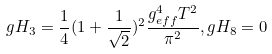<formula> <loc_0><loc_0><loc_500><loc_500>g H _ { 3 } = \frac { 1 } { 4 } ( 1 + \frac { 1 } { \sqrt { 2 } } ) ^ { 2 } \frac { g _ { e f f } ^ { 4 } T ^ { 2 } } { \pi ^ { 2 } } , g H _ { 8 } = 0</formula> 